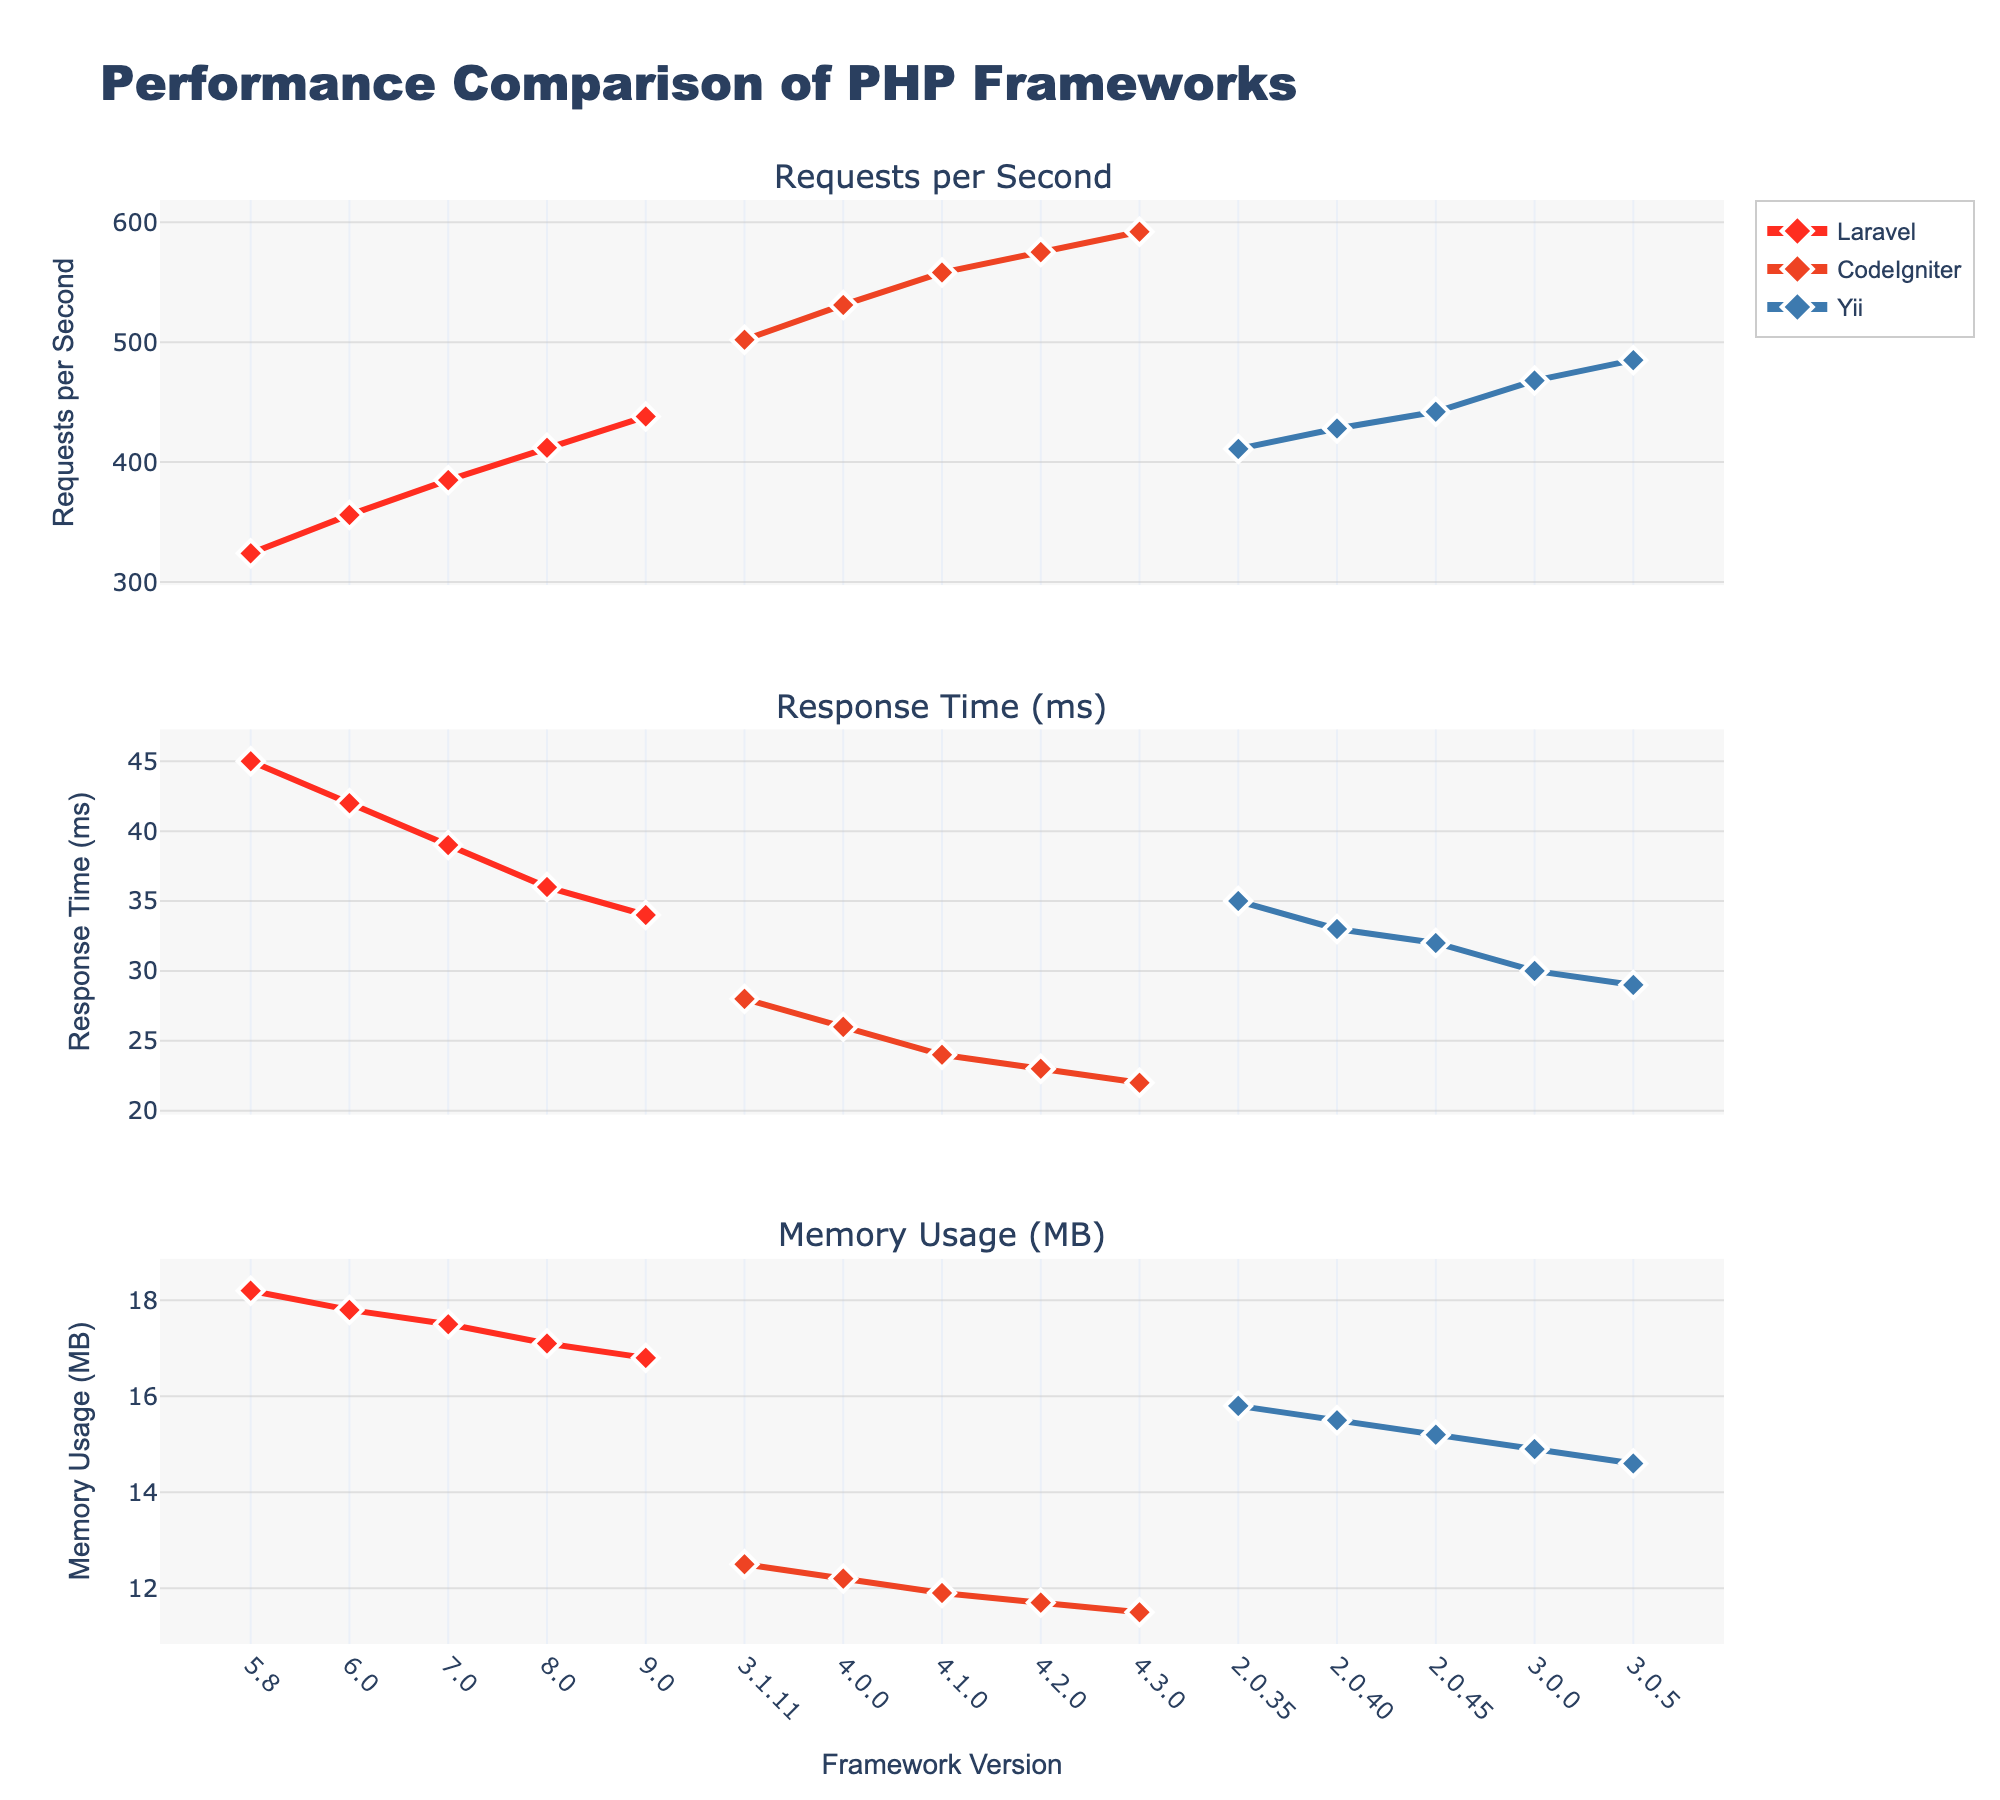What framework version has the highest requests per second? The highest line on the "Requests per Second" chart represents CodeIgniter at version 4.3.0.
Answer: CodeIgniter 4.3.0 Which framework demonstrates the lowest memory usage? The lowest line on the "Memory Usage (MB)" chart illustrates that CodeIgniter has the lowest memory usage, specifically at version 4.3.0.
Answer: CodeIgniter 4.3.0 How does the response time change in Laravel from version 5.8 to 9.0? The "Response Time (ms)" chart shows a decreasing trend for Laravel, starting at 45ms in version 5.8 and dropping to 34ms in version 9.0.
Answer: Decreases from 45ms to 34ms Between Yii 2.0.35 and Yii 3.0.0, by how much does the memory usage decrease? Subtract the memory usage of Yii 3.0.0 (14.9 MB) from Yii 2.0.35 (15.8 MB). The difference is 15.8 MB - 14.9 MB = 0.9 MB.
Answer: 0.9 MB Compare the requests per second between the latest versions of Laravel and Yii. Which is higher? Looking at the "Requests per Second" chart, the latest version of Laravel (9.0) can handle 438 requests per second, while Yii (3.0.5) can handle 485. Therefore, Yii is higher.
Answer: Yii What is the average response time across all versions of CodeIgniter? Calculate the mean of the response times for all versions of CodeIgniter: (28+26+24+23+22) / 5 = 24.6 ms.
Answer: 24.6 ms Which framework version has the smallest difference in response time compared to the previous version? Look at the "Response Time (ms)" chart and calculate the differences between subsequent versions for each framework. The smallest change is between Yii 2.0.45 and Yii 3.0.0 (32ms - 30ms = 2ms).
Answer: Yii (between 2.0.45 and 3.0.0) How does the memory usage trend of Yii compare to Laravel across their versions? On the "Memory Usage (MB)" chart, both Yii and Laravel show a decreasing trend, but Yii has a slightly more gradual decrease compared to Laravel.
Answer: Both decrease, Yii gradually Among the latest versions of all three frameworks shown, which has the lowest response time? Referring to the "Response Time (ms)" chart, CodeIgniter 4.3.0 has the lowest response time of 22ms compared to the latest versions of Laravel (34ms) and Yii (29ms).
Answer: CodeIgniter 4.3.0 